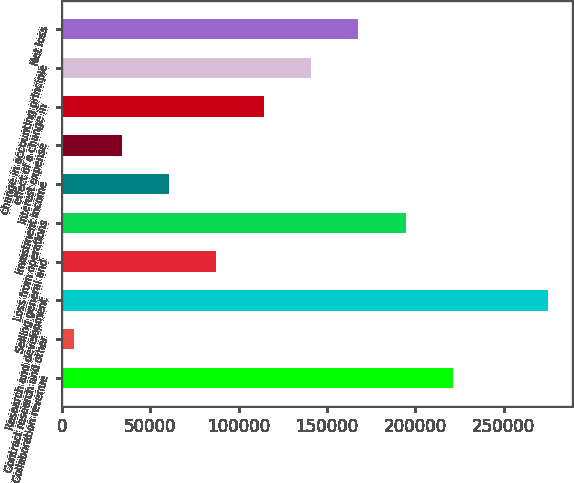Convert chart. <chart><loc_0><loc_0><loc_500><loc_500><bar_chart><fcel>Collaboration revenue<fcel>Contract research and other<fcel>Research and development<fcel>Selling general and<fcel>Loss from operations<fcel>Investment income<fcel>Interest expense<fcel>effect of a change in<fcel>change in accounting principle<fcel>Net loss<nl><fcel>221336<fcel>7070<fcel>274903<fcel>87419.9<fcel>194553<fcel>60636.6<fcel>33853.3<fcel>114203<fcel>140986<fcel>167770<nl></chart> 